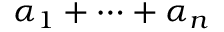<formula> <loc_0><loc_0><loc_500><loc_500>\alpha _ { 1 } + \cdots + \alpha _ { n }</formula> 